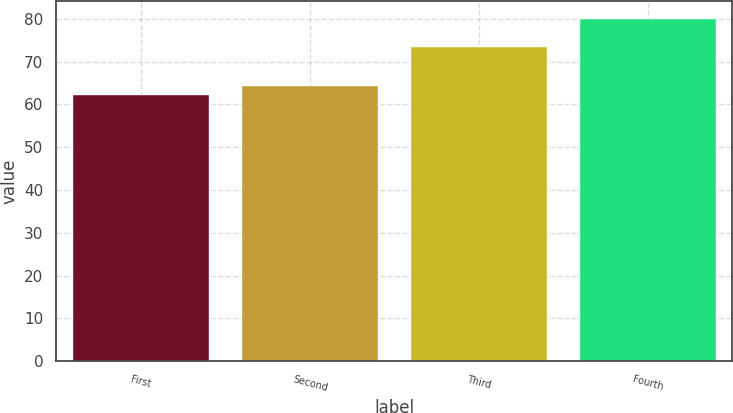Convert chart. <chart><loc_0><loc_0><loc_500><loc_500><bar_chart><fcel>First<fcel>Second<fcel>Third<fcel>Fourth<nl><fcel>62.18<fcel>64.24<fcel>73.43<fcel>80.03<nl></chart> 